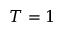Convert formula to latex. <formula><loc_0><loc_0><loc_500><loc_500>T = 1</formula> 